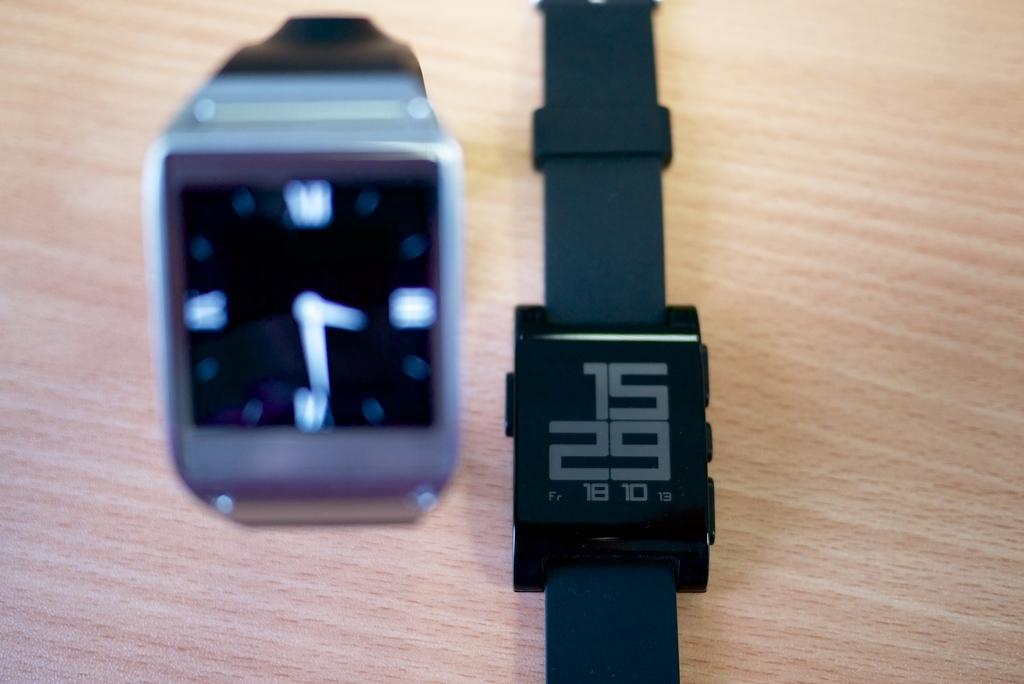What objects are in the center of the image? There are two watches in the center of the image. Can you describe the watches in the image? Unfortunately, the provided facts do not include any details about the watches' appearance or features. What type of linen is draped over the watches in the image? There is no linen present in the image; it only features two watches in the center. 